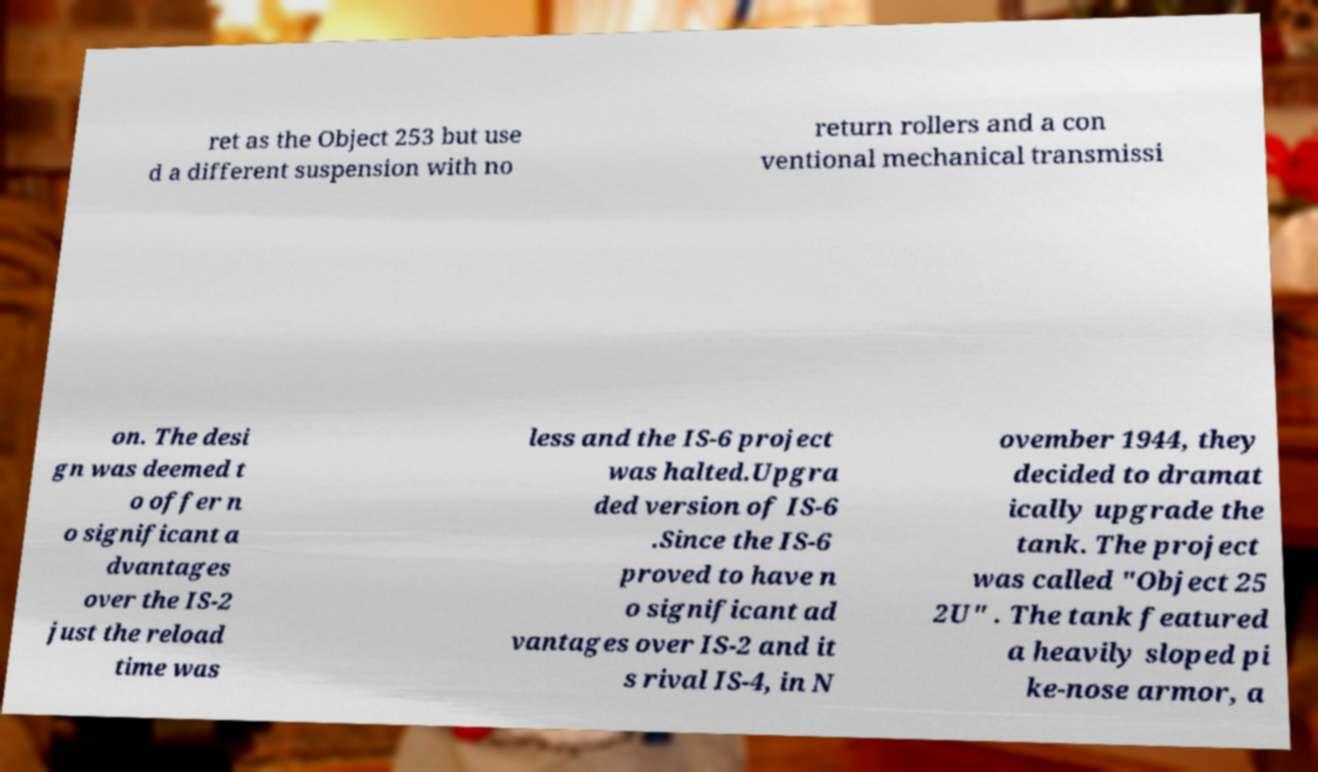Please identify and transcribe the text found in this image. ret as the Object 253 but use d a different suspension with no return rollers and a con ventional mechanical transmissi on. The desi gn was deemed t o offer n o significant a dvantages over the IS-2 just the reload time was less and the IS-6 project was halted.Upgra ded version of IS-6 .Since the IS-6 proved to have n o significant ad vantages over IS-2 and it s rival IS-4, in N ovember 1944, they decided to dramat ically upgrade the tank. The project was called "Object 25 2U" . The tank featured a heavily sloped pi ke-nose armor, a 